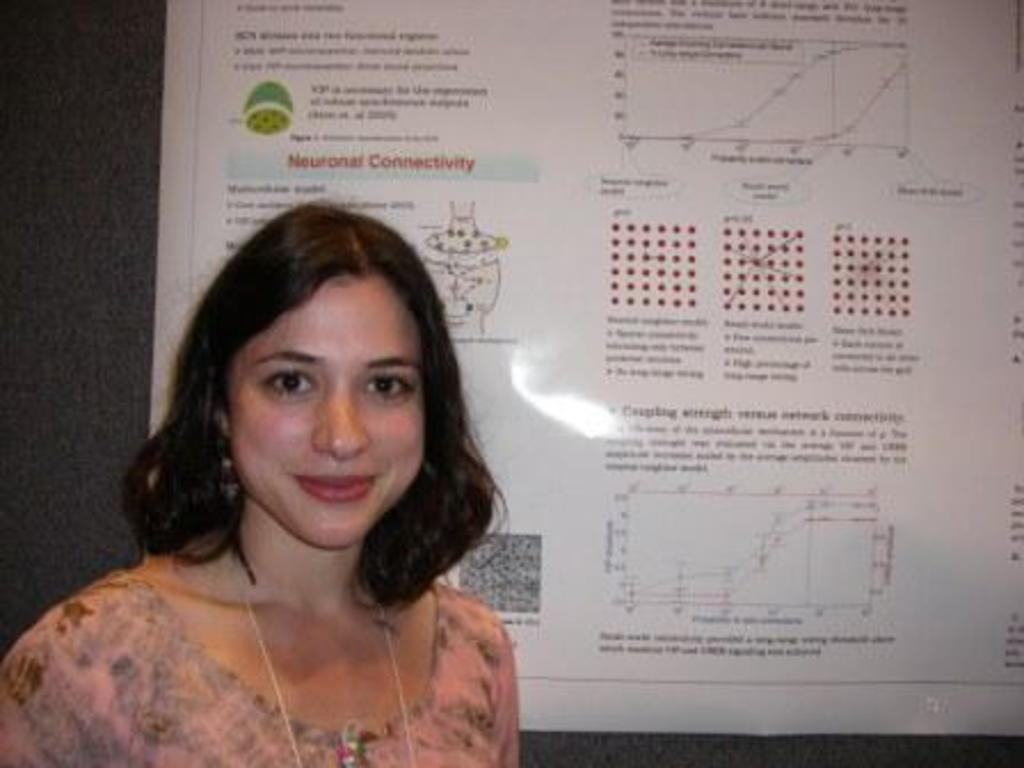Who is present in the image? There is a woman in the image. What is the woman's facial expression? The woman is smiling. What can be seen in the background of the image? There is a chart with diagrams and text in the background of the image. How is the chart positioned in the image? The chart is attached to the wall. What type of hill can be seen in the background of the image? There is no hill present in the image; it features a woman smiling and a chart with diagrams and text attached to the wall. 